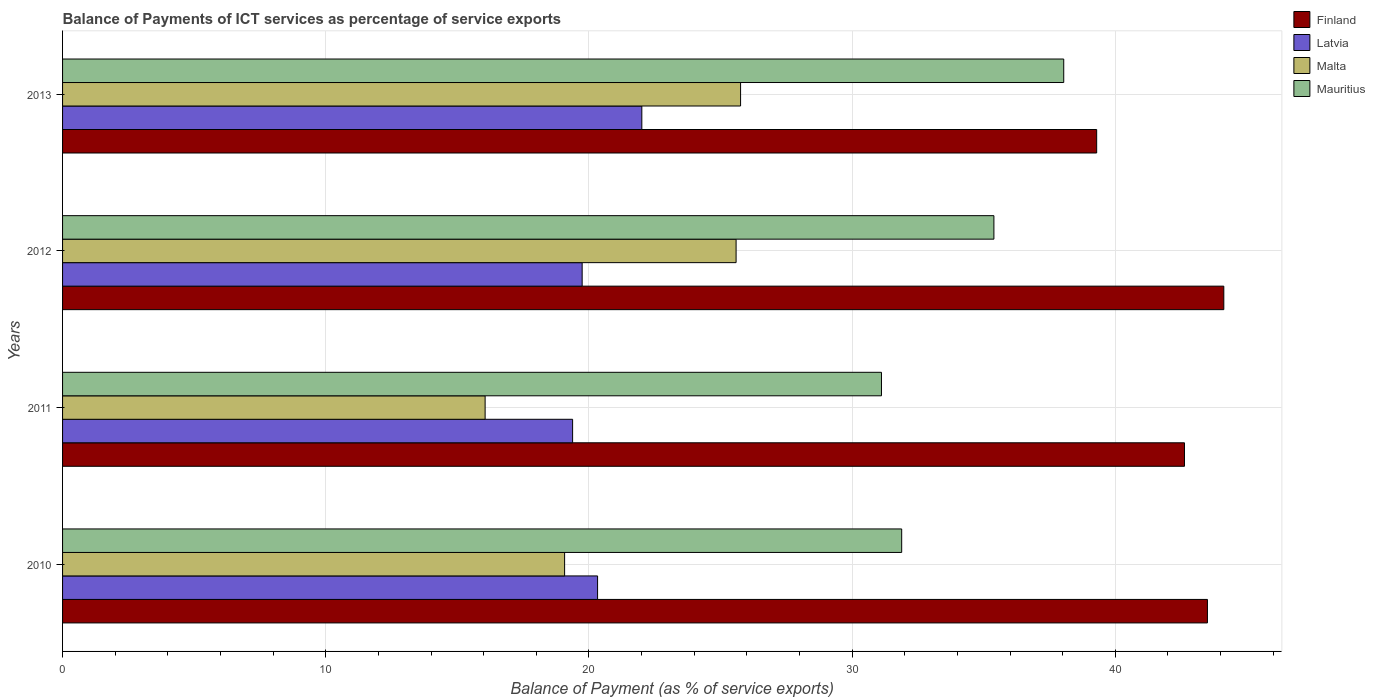How many different coloured bars are there?
Ensure brevity in your answer.  4. How many bars are there on the 2nd tick from the top?
Provide a succinct answer. 4. How many bars are there on the 1st tick from the bottom?
Provide a short and direct response. 4. What is the label of the 1st group of bars from the top?
Offer a very short reply. 2013. What is the balance of payments of ICT services in Finland in 2010?
Your response must be concise. 43.5. Across all years, what is the maximum balance of payments of ICT services in Malta?
Your answer should be compact. 25.76. Across all years, what is the minimum balance of payments of ICT services in Latvia?
Provide a short and direct response. 19.38. What is the total balance of payments of ICT services in Finland in the graph?
Provide a succinct answer. 169.55. What is the difference between the balance of payments of ICT services in Latvia in 2010 and that in 2012?
Give a very brief answer. 0.59. What is the difference between the balance of payments of ICT services in Latvia in 2010 and the balance of payments of ICT services in Mauritius in 2012?
Ensure brevity in your answer.  -15.06. What is the average balance of payments of ICT services in Finland per year?
Ensure brevity in your answer.  42.39. In the year 2010, what is the difference between the balance of payments of ICT services in Mauritius and balance of payments of ICT services in Latvia?
Give a very brief answer. 11.56. In how many years, is the balance of payments of ICT services in Mauritius greater than 38 %?
Your response must be concise. 1. What is the ratio of the balance of payments of ICT services in Mauritius in 2010 to that in 2013?
Make the answer very short. 0.84. What is the difference between the highest and the second highest balance of payments of ICT services in Mauritius?
Your response must be concise. 2.65. What is the difference between the highest and the lowest balance of payments of ICT services in Malta?
Provide a short and direct response. 9.71. Is it the case that in every year, the sum of the balance of payments of ICT services in Latvia and balance of payments of ICT services in Mauritius is greater than the sum of balance of payments of ICT services in Malta and balance of payments of ICT services in Finland?
Provide a short and direct response. Yes. What does the 2nd bar from the bottom in 2012 represents?
Provide a short and direct response. Latvia. Are all the bars in the graph horizontal?
Provide a succinct answer. Yes. Does the graph contain any zero values?
Make the answer very short. No. What is the title of the graph?
Provide a short and direct response. Balance of Payments of ICT services as percentage of service exports. What is the label or title of the X-axis?
Your answer should be compact. Balance of Payment (as % of service exports). What is the Balance of Payment (as % of service exports) in Finland in 2010?
Make the answer very short. 43.5. What is the Balance of Payment (as % of service exports) of Latvia in 2010?
Your response must be concise. 20.33. What is the Balance of Payment (as % of service exports) of Malta in 2010?
Your answer should be compact. 19.08. What is the Balance of Payment (as % of service exports) of Mauritius in 2010?
Your answer should be compact. 31.88. What is the Balance of Payment (as % of service exports) of Finland in 2011?
Your answer should be compact. 42.63. What is the Balance of Payment (as % of service exports) in Latvia in 2011?
Your answer should be compact. 19.38. What is the Balance of Payment (as % of service exports) in Malta in 2011?
Make the answer very short. 16.06. What is the Balance of Payment (as % of service exports) of Mauritius in 2011?
Provide a succinct answer. 31.12. What is the Balance of Payment (as % of service exports) in Finland in 2012?
Provide a short and direct response. 44.12. What is the Balance of Payment (as % of service exports) of Latvia in 2012?
Keep it short and to the point. 19.74. What is the Balance of Payment (as % of service exports) of Malta in 2012?
Offer a very short reply. 25.59. What is the Balance of Payment (as % of service exports) of Mauritius in 2012?
Provide a succinct answer. 35.39. What is the Balance of Payment (as % of service exports) in Finland in 2013?
Your answer should be very brief. 39.29. What is the Balance of Payment (as % of service exports) of Latvia in 2013?
Offer a terse response. 22.01. What is the Balance of Payment (as % of service exports) in Malta in 2013?
Ensure brevity in your answer.  25.76. What is the Balance of Payment (as % of service exports) in Mauritius in 2013?
Your answer should be very brief. 38.04. Across all years, what is the maximum Balance of Payment (as % of service exports) of Finland?
Ensure brevity in your answer.  44.12. Across all years, what is the maximum Balance of Payment (as % of service exports) of Latvia?
Keep it short and to the point. 22.01. Across all years, what is the maximum Balance of Payment (as % of service exports) in Malta?
Offer a terse response. 25.76. Across all years, what is the maximum Balance of Payment (as % of service exports) of Mauritius?
Make the answer very short. 38.04. Across all years, what is the minimum Balance of Payment (as % of service exports) of Finland?
Ensure brevity in your answer.  39.29. Across all years, what is the minimum Balance of Payment (as % of service exports) of Latvia?
Provide a succinct answer. 19.38. Across all years, what is the minimum Balance of Payment (as % of service exports) in Malta?
Provide a succinct answer. 16.06. Across all years, what is the minimum Balance of Payment (as % of service exports) of Mauritius?
Provide a short and direct response. 31.12. What is the total Balance of Payment (as % of service exports) in Finland in the graph?
Offer a very short reply. 169.55. What is the total Balance of Payment (as % of service exports) of Latvia in the graph?
Provide a short and direct response. 81.46. What is the total Balance of Payment (as % of service exports) in Malta in the graph?
Give a very brief answer. 86.49. What is the total Balance of Payment (as % of service exports) in Mauritius in the graph?
Your answer should be compact. 136.43. What is the difference between the Balance of Payment (as % of service exports) of Finland in 2010 and that in 2011?
Your response must be concise. 0.87. What is the difference between the Balance of Payment (as % of service exports) in Latvia in 2010 and that in 2011?
Keep it short and to the point. 0.95. What is the difference between the Balance of Payment (as % of service exports) of Malta in 2010 and that in 2011?
Ensure brevity in your answer.  3.02. What is the difference between the Balance of Payment (as % of service exports) of Mauritius in 2010 and that in 2011?
Your answer should be compact. 0.77. What is the difference between the Balance of Payment (as % of service exports) in Finland in 2010 and that in 2012?
Make the answer very short. -0.62. What is the difference between the Balance of Payment (as % of service exports) of Latvia in 2010 and that in 2012?
Provide a succinct answer. 0.59. What is the difference between the Balance of Payment (as % of service exports) of Malta in 2010 and that in 2012?
Provide a short and direct response. -6.52. What is the difference between the Balance of Payment (as % of service exports) in Mauritius in 2010 and that in 2012?
Your response must be concise. -3.5. What is the difference between the Balance of Payment (as % of service exports) in Finland in 2010 and that in 2013?
Your response must be concise. 4.21. What is the difference between the Balance of Payment (as % of service exports) in Latvia in 2010 and that in 2013?
Your answer should be compact. -1.68. What is the difference between the Balance of Payment (as % of service exports) of Malta in 2010 and that in 2013?
Keep it short and to the point. -6.69. What is the difference between the Balance of Payment (as % of service exports) of Mauritius in 2010 and that in 2013?
Make the answer very short. -6.16. What is the difference between the Balance of Payment (as % of service exports) in Finland in 2011 and that in 2012?
Your response must be concise. -1.49. What is the difference between the Balance of Payment (as % of service exports) of Latvia in 2011 and that in 2012?
Offer a very short reply. -0.36. What is the difference between the Balance of Payment (as % of service exports) in Malta in 2011 and that in 2012?
Ensure brevity in your answer.  -9.54. What is the difference between the Balance of Payment (as % of service exports) of Mauritius in 2011 and that in 2012?
Provide a succinct answer. -4.27. What is the difference between the Balance of Payment (as % of service exports) in Finland in 2011 and that in 2013?
Your response must be concise. 3.34. What is the difference between the Balance of Payment (as % of service exports) in Latvia in 2011 and that in 2013?
Provide a succinct answer. -2.63. What is the difference between the Balance of Payment (as % of service exports) in Malta in 2011 and that in 2013?
Keep it short and to the point. -9.71. What is the difference between the Balance of Payment (as % of service exports) in Mauritius in 2011 and that in 2013?
Make the answer very short. -6.93. What is the difference between the Balance of Payment (as % of service exports) of Finland in 2012 and that in 2013?
Offer a terse response. 4.83. What is the difference between the Balance of Payment (as % of service exports) in Latvia in 2012 and that in 2013?
Provide a succinct answer. -2.27. What is the difference between the Balance of Payment (as % of service exports) in Malta in 2012 and that in 2013?
Your answer should be compact. -0.17. What is the difference between the Balance of Payment (as % of service exports) of Mauritius in 2012 and that in 2013?
Give a very brief answer. -2.65. What is the difference between the Balance of Payment (as % of service exports) in Finland in 2010 and the Balance of Payment (as % of service exports) in Latvia in 2011?
Offer a very short reply. 24.12. What is the difference between the Balance of Payment (as % of service exports) of Finland in 2010 and the Balance of Payment (as % of service exports) of Malta in 2011?
Your response must be concise. 27.45. What is the difference between the Balance of Payment (as % of service exports) in Finland in 2010 and the Balance of Payment (as % of service exports) in Mauritius in 2011?
Your response must be concise. 12.39. What is the difference between the Balance of Payment (as % of service exports) in Latvia in 2010 and the Balance of Payment (as % of service exports) in Malta in 2011?
Your response must be concise. 4.27. What is the difference between the Balance of Payment (as % of service exports) in Latvia in 2010 and the Balance of Payment (as % of service exports) in Mauritius in 2011?
Offer a terse response. -10.79. What is the difference between the Balance of Payment (as % of service exports) in Malta in 2010 and the Balance of Payment (as % of service exports) in Mauritius in 2011?
Keep it short and to the point. -12.04. What is the difference between the Balance of Payment (as % of service exports) in Finland in 2010 and the Balance of Payment (as % of service exports) in Latvia in 2012?
Make the answer very short. 23.76. What is the difference between the Balance of Payment (as % of service exports) of Finland in 2010 and the Balance of Payment (as % of service exports) of Malta in 2012?
Offer a terse response. 17.91. What is the difference between the Balance of Payment (as % of service exports) of Finland in 2010 and the Balance of Payment (as % of service exports) of Mauritius in 2012?
Give a very brief answer. 8.11. What is the difference between the Balance of Payment (as % of service exports) of Latvia in 2010 and the Balance of Payment (as % of service exports) of Malta in 2012?
Offer a terse response. -5.26. What is the difference between the Balance of Payment (as % of service exports) in Latvia in 2010 and the Balance of Payment (as % of service exports) in Mauritius in 2012?
Offer a terse response. -15.06. What is the difference between the Balance of Payment (as % of service exports) of Malta in 2010 and the Balance of Payment (as % of service exports) of Mauritius in 2012?
Provide a succinct answer. -16.31. What is the difference between the Balance of Payment (as % of service exports) in Finland in 2010 and the Balance of Payment (as % of service exports) in Latvia in 2013?
Provide a short and direct response. 21.49. What is the difference between the Balance of Payment (as % of service exports) in Finland in 2010 and the Balance of Payment (as % of service exports) in Malta in 2013?
Keep it short and to the point. 17.74. What is the difference between the Balance of Payment (as % of service exports) in Finland in 2010 and the Balance of Payment (as % of service exports) in Mauritius in 2013?
Make the answer very short. 5.46. What is the difference between the Balance of Payment (as % of service exports) of Latvia in 2010 and the Balance of Payment (as % of service exports) of Malta in 2013?
Provide a short and direct response. -5.43. What is the difference between the Balance of Payment (as % of service exports) of Latvia in 2010 and the Balance of Payment (as % of service exports) of Mauritius in 2013?
Your answer should be very brief. -17.71. What is the difference between the Balance of Payment (as % of service exports) of Malta in 2010 and the Balance of Payment (as % of service exports) of Mauritius in 2013?
Ensure brevity in your answer.  -18.97. What is the difference between the Balance of Payment (as % of service exports) of Finland in 2011 and the Balance of Payment (as % of service exports) of Latvia in 2012?
Provide a succinct answer. 22.89. What is the difference between the Balance of Payment (as % of service exports) of Finland in 2011 and the Balance of Payment (as % of service exports) of Malta in 2012?
Give a very brief answer. 17.04. What is the difference between the Balance of Payment (as % of service exports) in Finland in 2011 and the Balance of Payment (as % of service exports) in Mauritius in 2012?
Make the answer very short. 7.24. What is the difference between the Balance of Payment (as % of service exports) in Latvia in 2011 and the Balance of Payment (as % of service exports) in Malta in 2012?
Your answer should be very brief. -6.21. What is the difference between the Balance of Payment (as % of service exports) of Latvia in 2011 and the Balance of Payment (as % of service exports) of Mauritius in 2012?
Give a very brief answer. -16.01. What is the difference between the Balance of Payment (as % of service exports) of Malta in 2011 and the Balance of Payment (as % of service exports) of Mauritius in 2012?
Your response must be concise. -19.33. What is the difference between the Balance of Payment (as % of service exports) in Finland in 2011 and the Balance of Payment (as % of service exports) in Latvia in 2013?
Give a very brief answer. 20.62. What is the difference between the Balance of Payment (as % of service exports) of Finland in 2011 and the Balance of Payment (as % of service exports) of Malta in 2013?
Keep it short and to the point. 16.87. What is the difference between the Balance of Payment (as % of service exports) of Finland in 2011 and the Balance of Payment (as % of service exports) of Mauritius in 2013?
Keep it short and to the point. 4.59. What is the difference between the Balance of Payment (as % of service exports) of Latvia in 2011 and the Balance of Payment (as % of service exports) of Malta in 2013?
Make the answer very short. -6.38. What is the difference between the Balance of Payment (as % of service exports) of Latvia in 2011 and the Balance of Payment (as % of service exports) of Mauritius in 2013?
Your response must be concise. -18.66. What is the difference between the Balance of Payment (as % of service exports) in Malta in 2011 and the Balance of Payment (as % of service exports) in Mauritius in 2013?
Keep it short and to the point. -21.99. What is the difference between the Balance of Payment (as % of service exports) in Finland in 2012 and the Balance of Payment (as % of service exports) in Latvia in 2013?
Keep it short and to the point. 22.11. What is the difference between the Balance of Payment (as % of service exports) of Finland in 2012 and the Balance of Payment (as % of service exports) of Malta in 2013?
Keep it short and to the point. 18.36. What is the difference between the Balance of Payment (as % of service exports) in Finland in 2012 and the Balance of Payment (as % of service exports) in Mauritius in 2013?
Keep it short and to the point. 6.08. What is the difference between the Balance of Payment (as % of service exports) in Latvia in 2012 and the Balance of Payment (as % of service exports) in Malta in 2013?
Keep it short and to the point. -6.02. What is the difference between the Balance of Payment (as % of service exports) in Latvia in 2012 and the Balance of Payment (as % of service exports) in Mauritius in 2013?
Offer a very short reply. -18.3. What is the difference between the Balance of Payment (as % of service exports) of Malta in 2012 and the Balance of Payment (as % of service exports) of Mauritius in 2013?
Your answer should be compact. -12.45. What is the average Balance of Payment (as % of service exports) in Finland per year?
Keep it short and to the point. 42.39. What is the average Balance of Payment (as % of service exports) in Latvia per year?
Ensure brevity in your answer.  20.37. What is the average Balance of Payment (as % of service exports) of Malta per year?
Your response must be concise. 21.62. What is the average Balance of Payment (as % of service exports) of Mauritius per year?
Your response must be concise. 34.11. In the year 2010, what is the difference between the Balance of Payment (as % of service exports) in Finland and Balance of Payment (as % of service exports) in Latvia?
Your answer should be very brief. 23.17. In the year 2010, what is the difference between the Balance of Payment (as % of service exports) in Finland and Balance of Payment (as % of service exports) in Malta?
Offer a terse response. 24.43. In the year 2010, what is the difference between the Balance of Payment (as % of service exports) of Finland and Balance of Payment (as % of service exports) of Mauritius?
Offer a terse response. 11.62. In the year 2010, what is the difference between the Balance of Payment (as % of service exports) of Latvia and Balance of Payment (as % of service exports) of Malta?
Your response must be concise. 1.25. In the year 2010, what is the difference between the Balance of Payment (as % of service exports) in Latvia and Balance of Payment (as % of service exports) in Mauritius?
Keep it short and to the point. -11.56. In the year 2010, what is the difference between the Balance of Payment (as % of service exports) of Malta and Balance of Payment (as % of service exports) of Mauritius?
Keep it short and to the point. -12.81. In the year 2011, what is the difference between the Balance of Payment (as % of service exports) in Finland and Balance of Payment (as % of service exports) in Latvia?
Offer a terse response. 23.25. In the year 2011, what is the difference between the Balance of Payment (as % of service exports) of Finland and Balance of Payment (as % of service exports) of Malta?
Offer a terse response. 26.57. In the year 2011, what is the difference between the Balance of Payment (as % of service exports) in Finland and Balance of Payment (as % of service exports) in Mauritius?
Make the answer very short. 11.51. In the year 2011, what is the difference between the Balance of Payment (as % of service exports) in Latvia and Balance of Payment (as % of service exports) in Malta?
Your answer should be compact. 3.32. In the year 2011, what is the difference between the Balance of Payment (as % of service exports) in Latvia and Balance of Payment (as % of service exports) in Mauritius?
Your answer should be very brief. -11.74. In the year 2011, what is the difference between the Balance of Payment (as % of service exports) of Malta and Balance of Payment (as % of service exports) of Mauritius?
Your response must be concise. -15.06. In the year 2012, what is the difference between the Balance of Payment (as % of service exports) in Finland and Balance of Payment (as % of service exports) in Latvia?
Your answer should be compact. 24.38. In the year 2012, what is the difference between the Balance of Payment (as % of service exports) in Finland and Balance of Payment (as % of service exports) in Malta?
Keep it short and to the point. 18.53. In the year 2012, what is the difference between the Balance of Payment (as % of service exports) in Finland and Balance of Payment (as % of service exports) in Mauritius?
Your answer should be compact. 8.74. In the year 2012, what is the difference between the Balance of Payment (as % of service exports) of Latvia and Balance of Payment (as % of service exports) of Malta?
Provide a short and direct response. -5.85. In the year 2012, what is the difference between the Balance of Payment (as % of service exports) in Latvia and Balance of Payment (as % of service exports) in Mauritius?
Offer a very short reply. -15.65. In the year 2012, what is the difference between the Balance of Payment (as % of service exports) of Malta and Balance of Payment (as % of service exports) of Mauritius?
Your answer should be very brief. -9.8. In the year 2013, what is the difference between the Balance of Payment (as % of service exports) in Finland and Balance of Payment (as % of service exports) in Latvia?
Ensure brevity in your answer.  17.28. In the year 2013, what is the difference between the Balance of Payment (as % of service exports) of Finland and Balance of Payment (as % of service exports) of Malta?
Keep it short and to the point. 13.53. In the year 2013, what is the difference between the Balance of Payment (as % of service exports) in Finland and Balance of Payment (as % of service exports) in Mauritius?
Provide a succinct answer. 1.25. In the year 2013, what is the difference between the Balance of Payment (as % of service exports) in Latvia and Balance of Payment (as % of service exports) in Malta?
Your response must be concise. -3.75. In the year 2013, what is the difference between the Balance of Payment (as % of service exports) of Latvia and Balance of Payment (as % of service exports) of Mauritius?
Make the answer very short. -16.03. In the year 2013, what is the difference between the Balance of Payment (as % of service exports) in Malta and Balance of Payment (as % of service exports) in Mauritius?
Offer a very short reply. -12.28. What is the ratio of the Balance of Payment (as % of service exports) in Finland in 2010 to that in 2011?
Give a very brief answer. 1.02. What is the ratio of the Balance of Payment (as % of service exports) in Latvia in 2010 to that in 2011?
Make the answer very short. 1.05. What is the ratio of the Balance of Payment (as % of service exports) of Malta in 2010 to that in 2011?
Provide a short and direct response. 1.19. What is the ratio of the Balance of Payment (as % of service exports) in Mauritius in 2010 to that in 2011?
Provide a succinct answer. 1.02. What is the ratio of the Balance of Payment (as % of service exports) in Finland in 2010 to that in 2012?
Make the answer very short. 0.99. What is the ratio of the Balance of Payment (as % of service exports) of Latvia in 2010 to that in 2012?
Make the answer very short. 1.03. What is the ratio of the Balance of Payment (as % of service exports) in Malta in 2010 to that in 2012?
Offer a terse response. 0.75. What is the ratio of the Balance of Payment (as % of service exports) in Mauritius in 2010 to that in 2012?
Make the answer very short. 0.9. What is the ratio of the Balance of Payment (as % of service exports) in Finland in 2010 to that in 2013?
Your answer should be compact. 1.11. What is the ratio of the Balance of Payment (as % of service exports) in Latvia in 2010 to that in 2013?
Make the answer very short. 0.92. What is the ratio of the Balance of Payment (as % of service exports) in Malta in 2010 to that in 2013?
Ensure brevity in your answer.  0.74. What is the ratio of the Balance of Payment (as % of service exports) in Mauritius in 2010 to that in 2013?
Offer a very short reply. 0.84. What is the ratio of the Balance of Payment (as % of service exports) in Finland in 2011 to that in 2012?
Your answer should be compact. 0.97. What is the ratio of the Balance of Payment (as % of service exports) of Latvia in 2011 to that in 2012?
Your answer should be very brief. 0.98. What is the ratio of the Balance of Payment (as % of service exports) in Malta in 2011 to that in 2012?
Ensure brevity in your answer.  0.63. What is the ratio of the Balance of Payment (as % of service exports) in Mauritius in 2011 to that in 2012?
Your answer should be very brief. 0.88. What is the ratio of the Balance of Payment (as % of service exports) of Finland in 2011 to that in 2013?
Your answer should be very brief. 1.08. What is the ratio of the Balance of Payment (as % of service exports) in Latvia in 2011 to that in 2013?
Offer a very short reply. 0.88. What is the ratio of the Balance of Payment (as % of service exports) in Malta in 2011 to that in 2013?
Give a very brief answer. 0.62. What is the ratio of the Balance of Payment (as % of service exports) in Mauritius in 2011 to that in 2013?
Provide a succinct answer. 0.82. What is the ratio of the Balance of Payment (as % of service exports) in Finland in 2012 to that in 2013?
Keep it short and to the point. 1.12. What is the ratio of the Balance of Payment (as % of service exports) in Latvia in 2012 to that in 2013?
Offer a terse response. 0.9. What is the ratio of the Balance of Payment (as % of service exports) in Malta in 2012 to that in 2013?
Offer a very short reply. 0.99. What is the ratio of the Balance of Payment (as % of service exports) in Mauritius in 2012 to that in 2013?
Your response must be concise. 0.93. What is the difference between the highest and the second highest Balance of Payment (as % of service exports) in Finland?
Your answer should be compact. 0.62. What is the difference between the highest and the second highest Balance of Payment (as % of service exports) in Latvia?
Make the answer very short. 1.68. What is the difference between the highest and the second highest Balance of Payment (as % of service exports) of Malta?
Make the answer very short. 0.17. What is the difference between the highest and the second highest Balance of Payment (as % of service exports) in Mauritius?
Your answer should be compact. 2.65. What is the difference between the highest and the lowest Balance of Payment (as % of service exports) of Finland?
Offer a very short reply. 4.83. What is the difference between the highest and the lowest Balance of Payment (as % of service exports) of Latvia?
Your answer should be very brief. 2.63. What is the difference between the highest and the lowest Balance of Payment (as % of service exports) in Malta?
Ensure brevity in your answer.  9.71. What is the difference between the highest and the lowest Balance of Payment (as % of service exports) of Mauritius?
Your response must be concise. 6.93. 